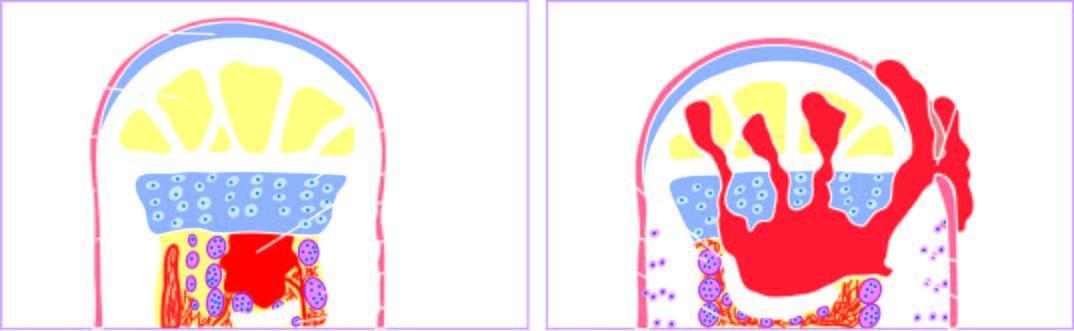what is called involucrum?
Answer the question using a single word or phrase. Formation of viable new reactive bone surrounding the sequestrum 